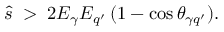<formula> <loc_0><loc_0><loc_500><loc_500>\hat { s } \, > \, 2 E _ { \gamma } E _ { q ^ { \prime } } \, ( 1 - \cos \theta _ { \gamma q ^ { \prime } } ) .</formula> 